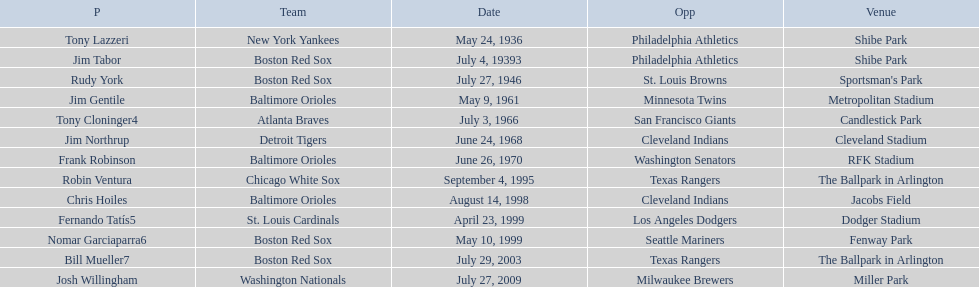What were the dates of each game? May 24, 1936, July 4, 19393, July 27, 1946, May 9, 1961, July 3, 1966, June 24, 1968, June 26, 1970, September 4, 1995, August 14, 1998, April 23, 1999, May 10, 1999, July 29, 2003, July 27, 2009. Who were all of the teams? New York Yankees, Boston Red Sox, Boston Red Sox, Baltimore Orioles, Atlanta Braves, Detroit Tigers, Baltimore Orioles, Chicago White Sox, Baltimore Orioles, St. Louis Cardinals, Boston Red Sox, Boston Red Sox, Washington Nationals. What about their opponents? Philadelphia Athletics, Philadelphia Athletics, St. Louis Browns, Minnesota Twins, San Francisco Giants, Cleveland Indians, Washington Senators, Texas Rangers, Cleveland Indians, Los Angeles Dodgers, Seattle Mariners, Texas Rangers, Milwaukee Brewers. And on which date did the detroit tigers play against the cleveland indians? June 24, 1968. 